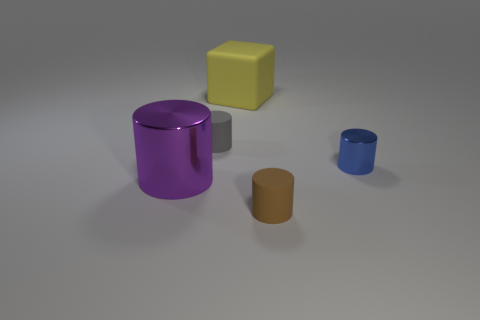Subtract all brown cylinders. How many cylinders are left? 3 Subtract all big purple cylinders. How many cylinders are left? 3 Subtract all yellow cylinders. Subtract all brown spheres. How many cylinders are left? 4 Add 1 big gray metallic spheres. How many objects exist? 6 Subtract 0 brown spheres. How many objects are left? 5 Subtract all cubes. How many objects are left? 4 Subtract all rubber things. Subtract all red spheres. How many objects are left? 2 Add 5 yellow cubes. How many yellow cubes are left? 6 Add 1 brown matte cylinders. How many brown matte cylinders exist? 2 